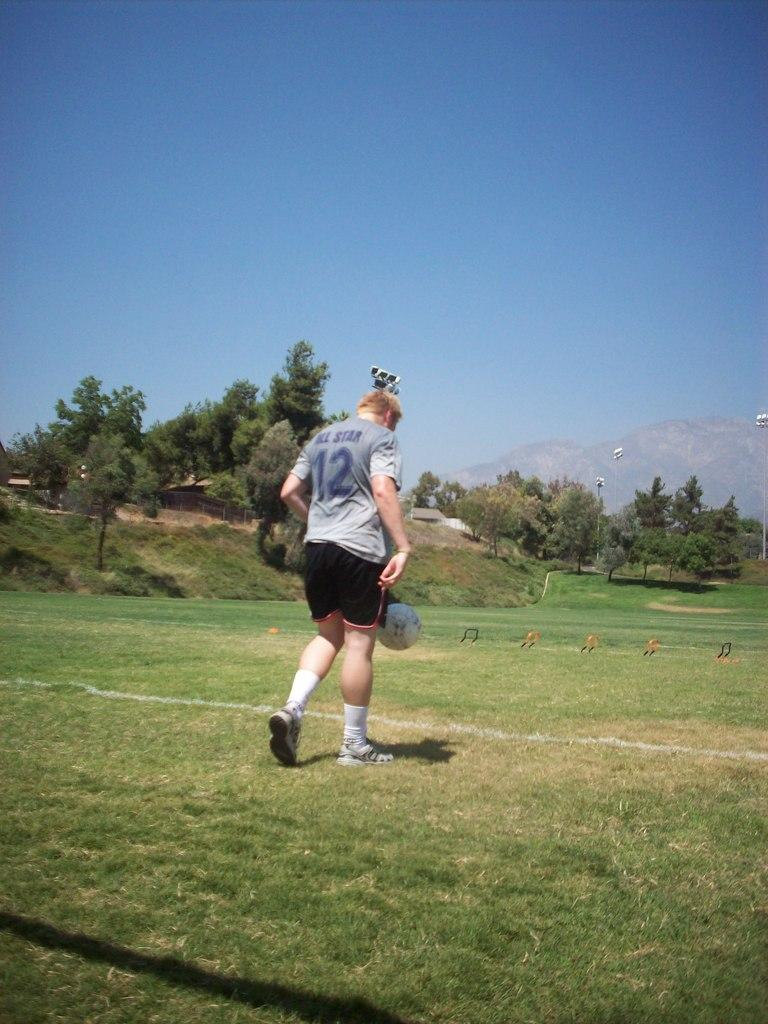<image>
Offer a succinct explanation of the picture presented. A man playing soccer with a shirt that says All star 12. 